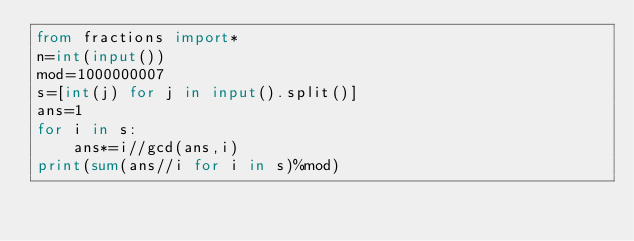<code> <loc_0><loc_0><loc_500><loc_500><_Python_>from fractions import*
n=int(input())
mod=1000000007
s=[int(j) for j in input().split()]
ans=1
for i in s:
    ans*=i//gcd(ans,i)
print(sum(ans//i for i in s)%mod)
</code> 